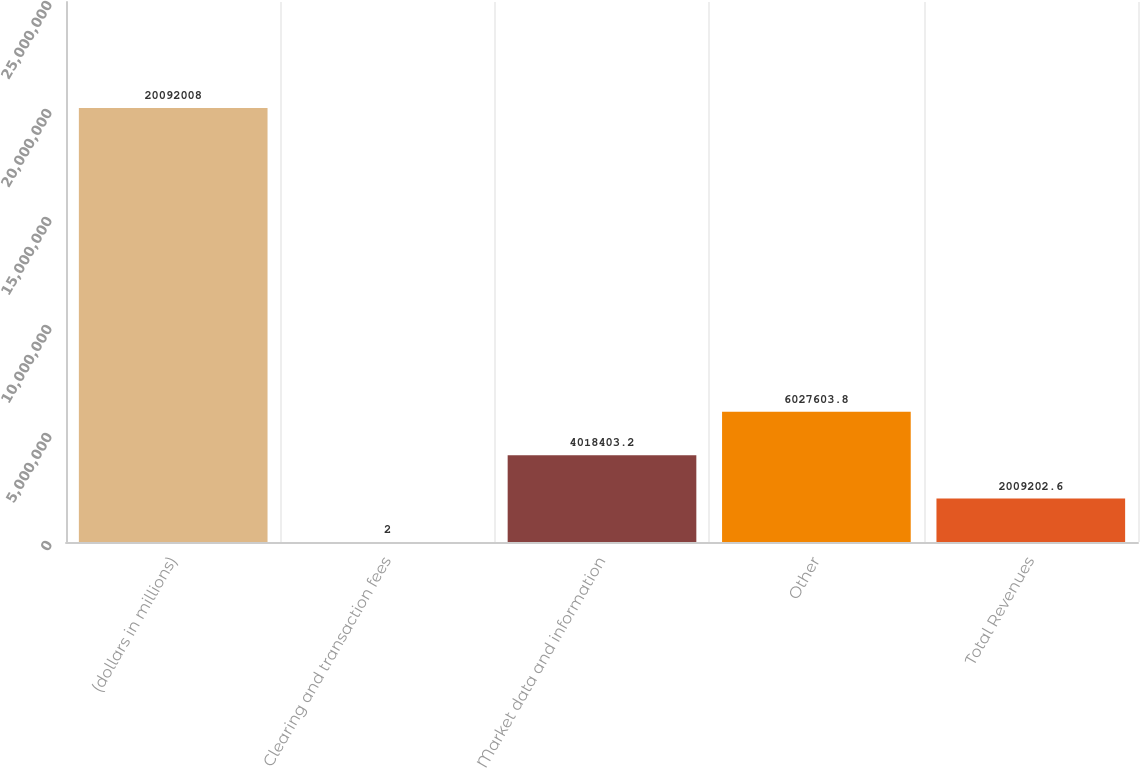Convert chart. <chart><loc_0><loc_0><loc_500><loc_500><bar_chart><fcel>(dollars in millions)<fcel>Clearing and transaction fees<fcel>Market data and information<fcel>Other<fcel>Total Revenues<nl><fcel>2.0092e+07<fcel>2<fcel>4.0184e+06<fcel>6.0276e+06<fcel>2.0092e+06<nl></chart> 